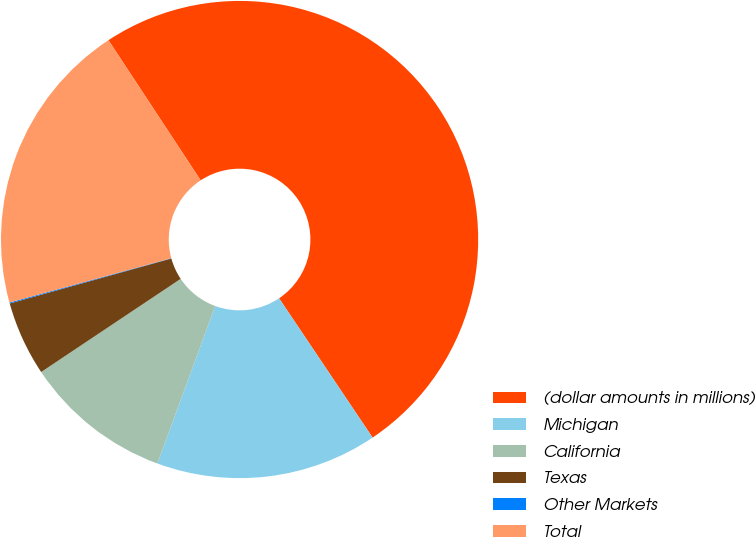Convert chart. <chart><loc_0><loc_0><loc_500><loc_500><pie_chart><fcel>(dollar amounts in millions)<fcel>Michigan<fcel>California<fcel>Texas<fcel>Other Markets<fcel>Total<nl><fcel>49.85%<fcel>15.01%<fcel>10.03%<fcel>5.05%<fcel>0.07%<fcel>19.99%<nl></chart> 